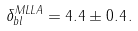<formula> <loc_0><loc_0><loc_500><loc_500>\delta _ { b l } ^ { M L L A } = 4 . 4 \pm 0 . 4 \, .</formula> 